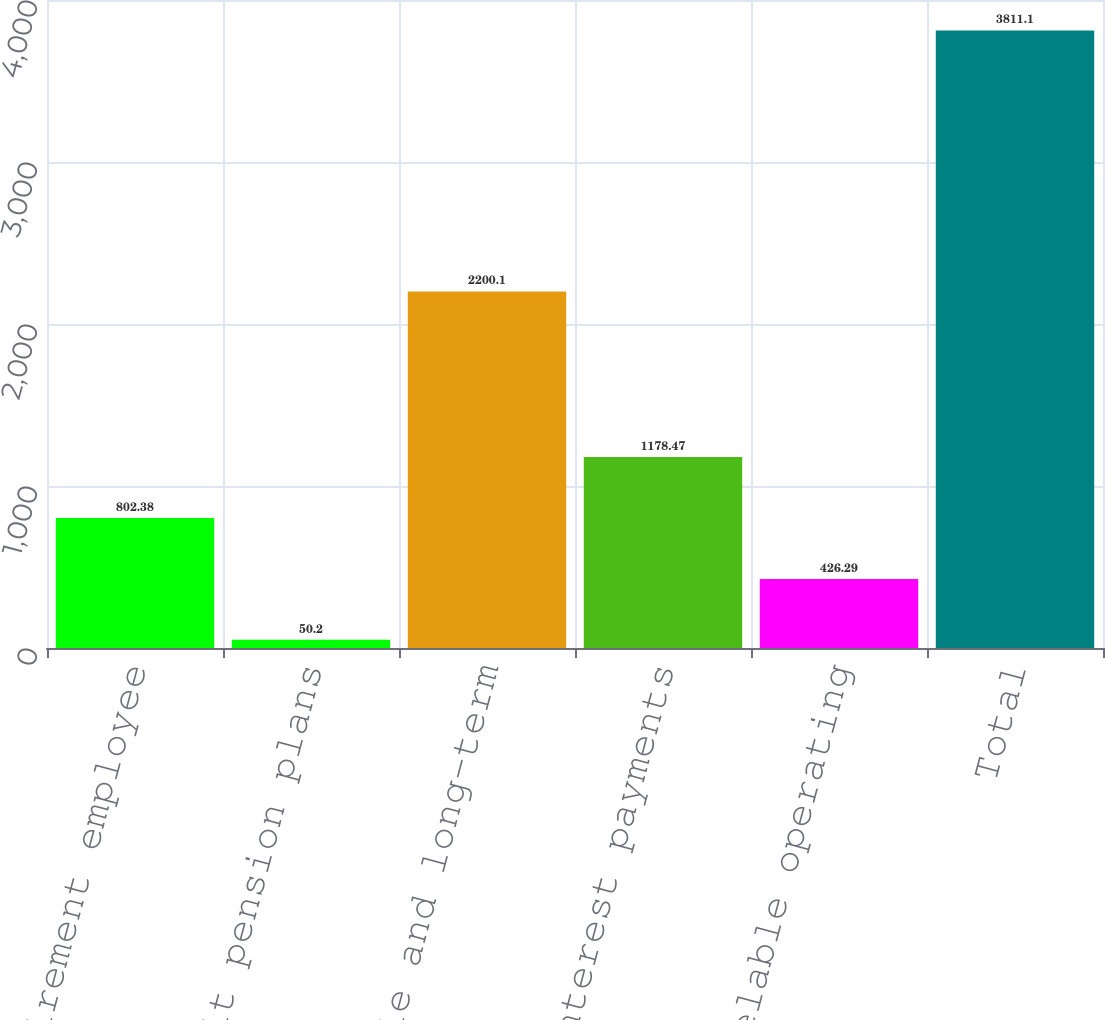Convert chart. <chart><loc_0><loc_0><loc_500><loc_500><bar_chart><fcel>Other postretirement employee<fcel>Defined benefit pension plans<fcel>Notes payable and long-term<fcel>Projected interest payments<fcel>Non-cancelable operating<fcel>Total<nl><fcel>802.38<fcel>50.2<fcel>2200.1<fcel>1178.47<fcel>426.29<fcel>3811.1<nl></chart> 